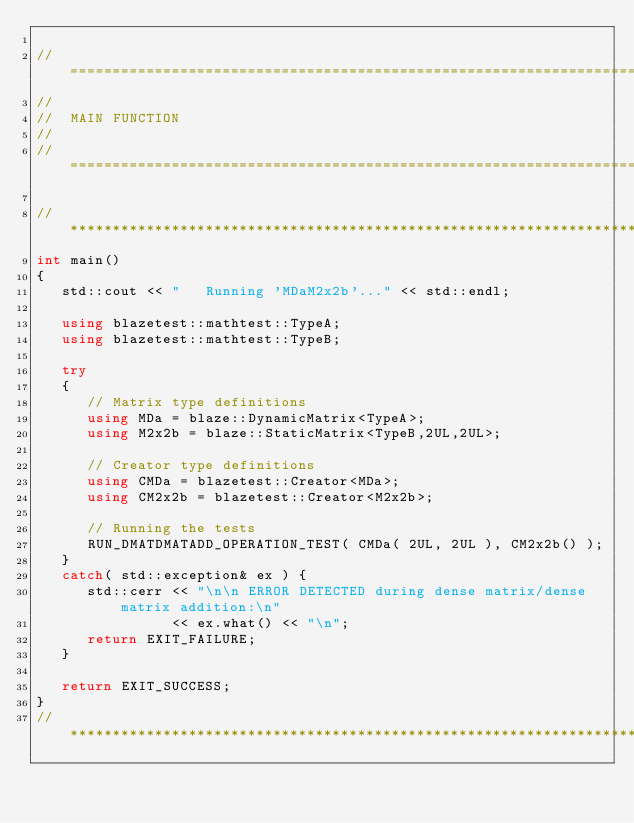Convert code to text. <code><loc_0><loc_0><loc_500><loc_500><_C++_>
//=================================================================================================
//
//  MAIN FUNCTION
//
//=================================================================================================

//*************************************************************************************************
int main()
{
   std::cout << "   Running 'MDaM2x2b'..." << std::endl;

   using blazetest::mathtest::TypeA;
   using blazetest::mathtest::TypeB;

   try
   {
      // Matrix type definitions
      using MDa = blaze::DynamicMatrix<TypeA>;
      using M2x2b = blaze::StaticMatrix<TypeB,2UL,2UL>;

      // Creator type definitions
      using CMDa = blazetest::Creator<MDa>;
      using CM2x2b = blazetest::Creator<M2x2b>;

      // Running the tests
      RUN_DMATDMATADD_OPERATION_TEST( CMDa( 2UL, 2UL ), CM2x2b() );
   }
   catch( std::exception& ex ) {
      std::cerr << "\n\n ERROR DETECTED during dense matrix/dense matrix addition:\n"
                << ex.what() << "\n";
      return EXIT_FAILURE;
   }

   return EXIT_SUCCESS;
}
//*************************************************************************************************
</code> 